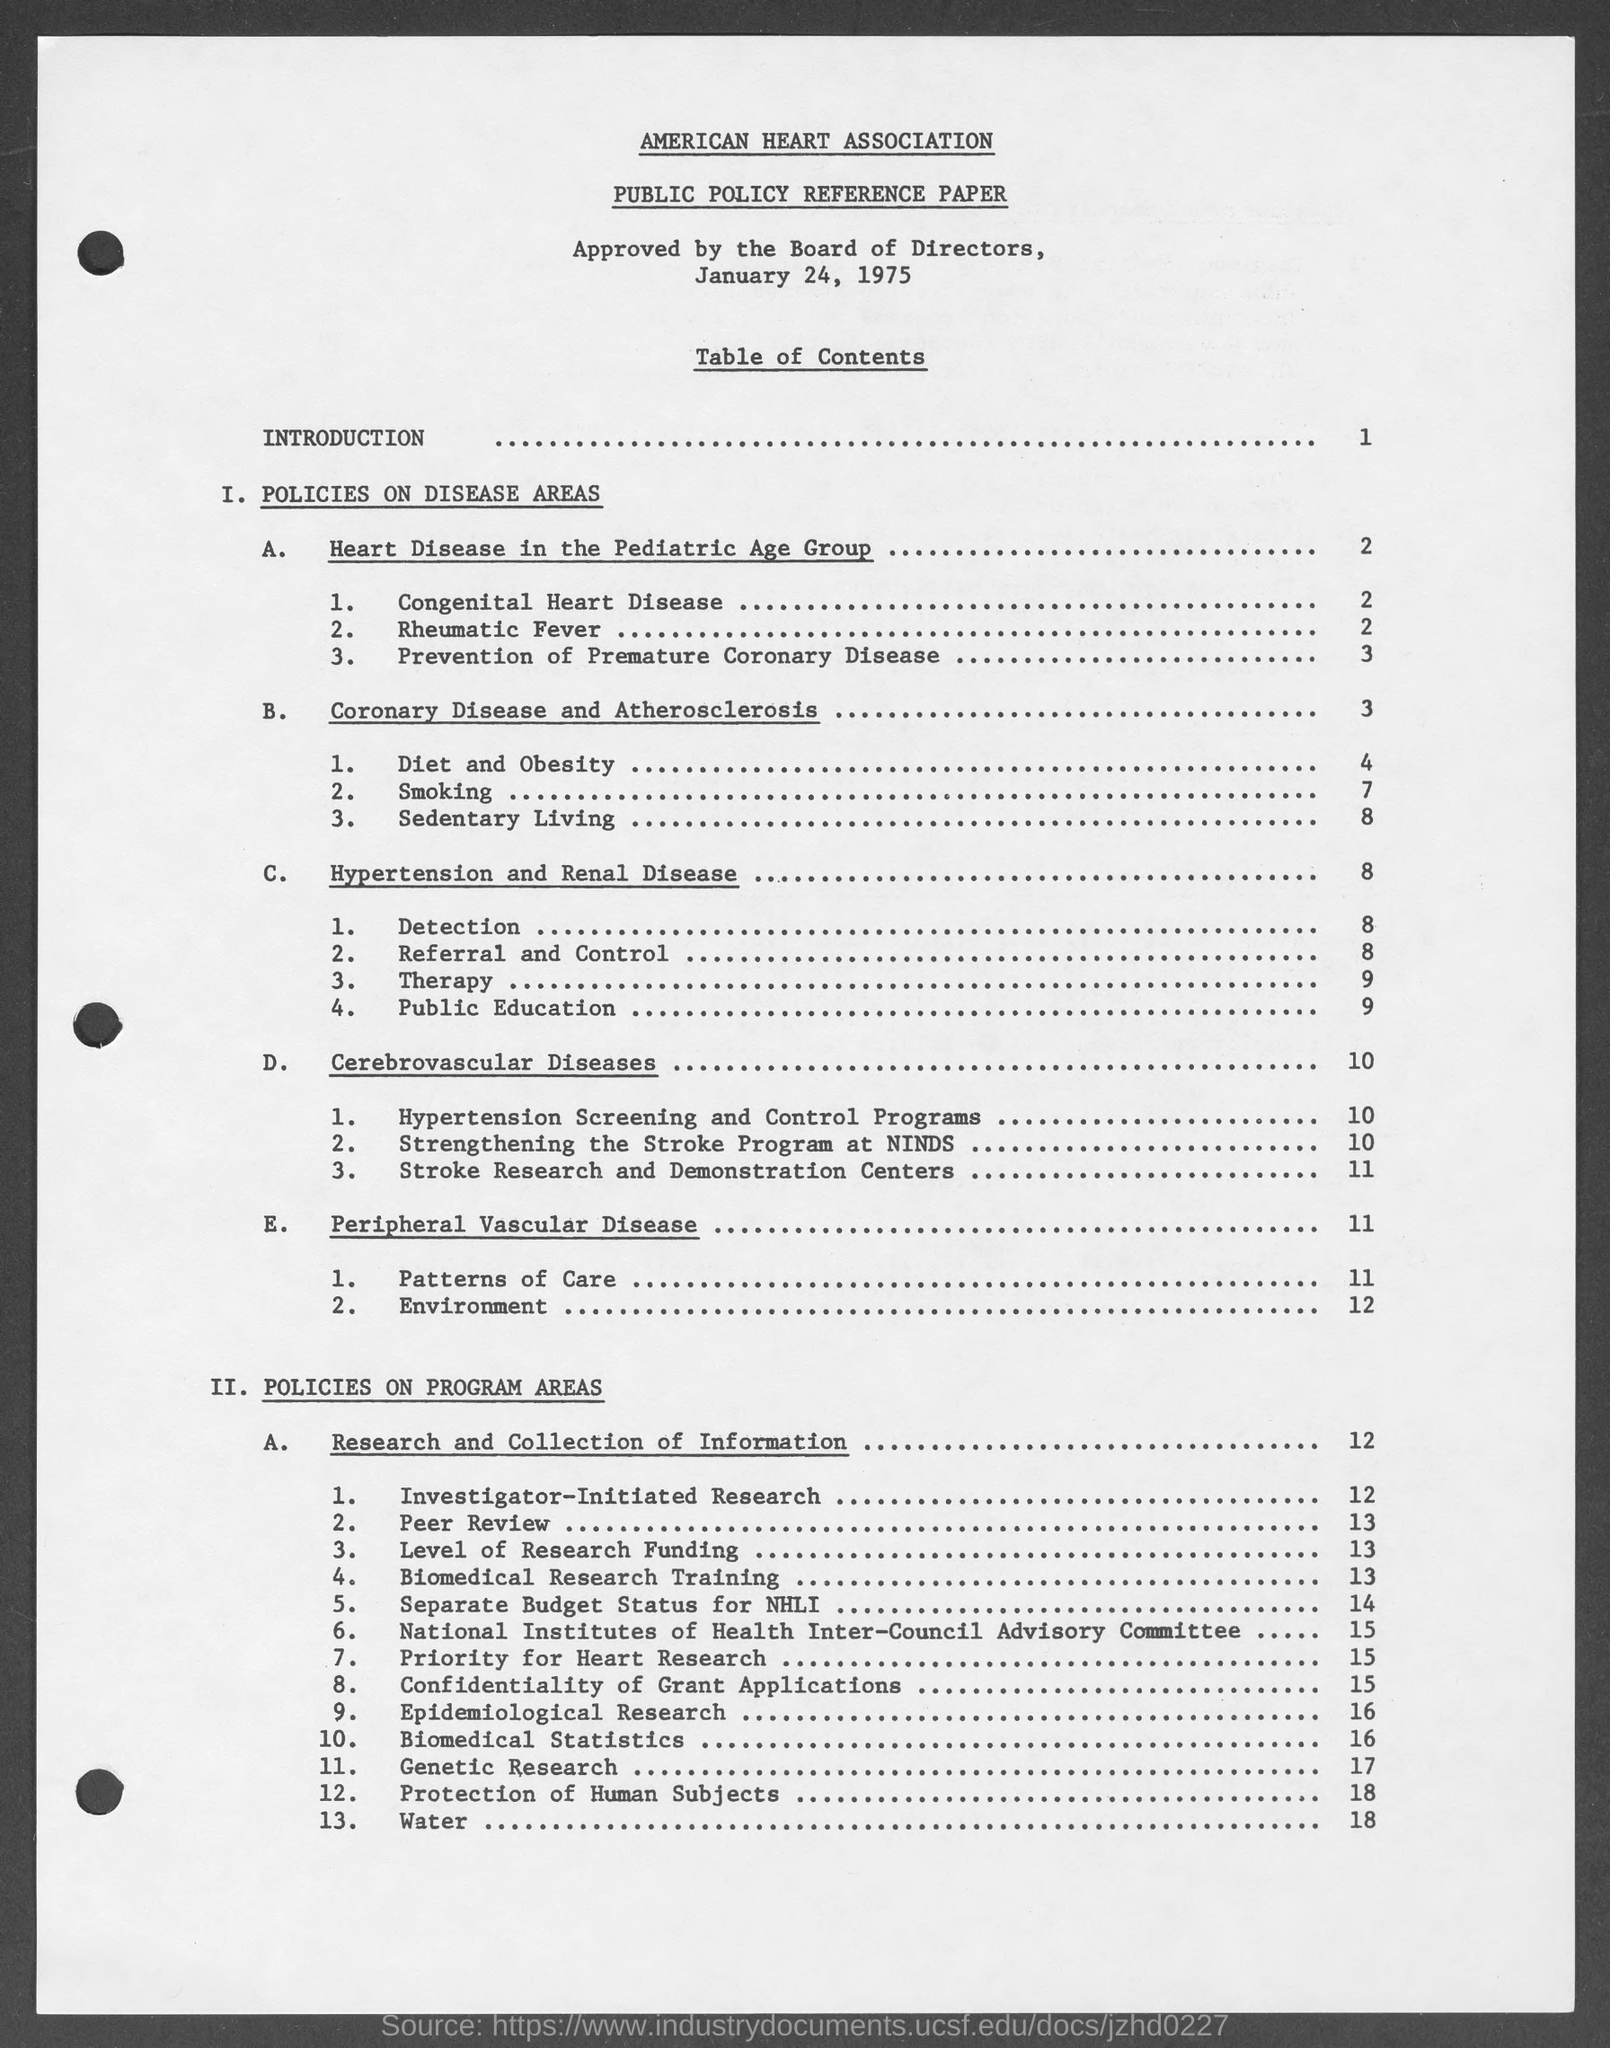What is the name of the paper mentioned in the given page ?
Your answer should be compact. Public policy reference paper. What is the name of the association mentioned in the given page ?
Ensure brevity in your answer.  American heart association. What is the date mentioned in the given page ?
Provide a short and direct response. January 24, 1975. What is there in page 1 ?
Provide a short and direct response. Introduction. What is mentioned in page 4 ?
Provide a short and direct response. Diet and obesity. Which type of disease is mentioned in page 8 ?
Your response must be concise. Hypertension and renal disease. Which type of disease is mentioned in page 10 ?
Make the answer very short. Cerebrovascular diseases. Which type of diseases are mentioned in page 11 ?
Ensure brevity in your answer.  Peripheral vascular disease. 